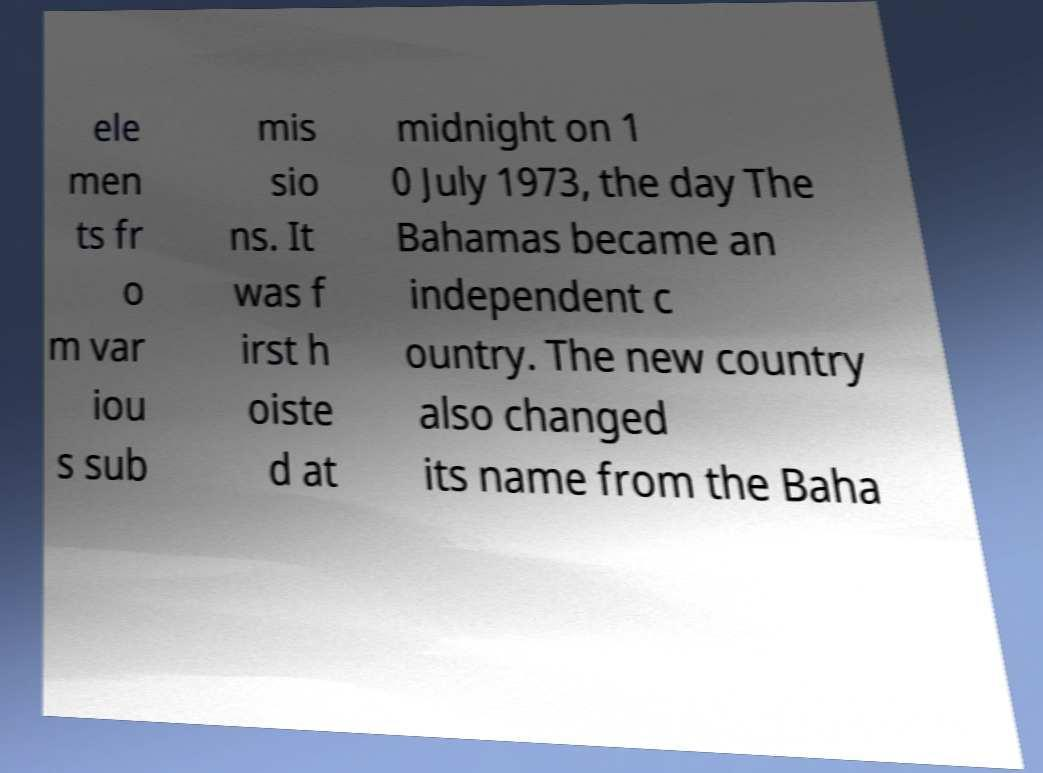Could you assist in decoding the text presented in this image and type it out clearly? ele men ts fr o m var iou s sub mis sio ns. It was f irst h oiste d at midnight on 1 0 July 1973, the day The Bahamas became an independent c ountry. The new country also changed its name from the Baha 